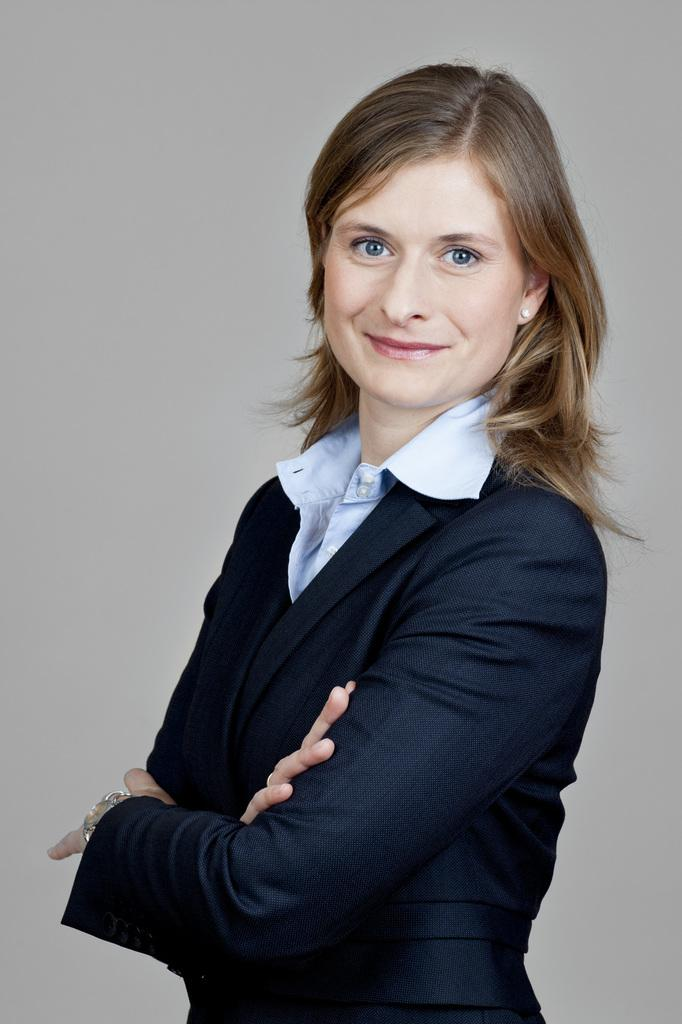Who is present in the image? There is a woman in the image. What expression does the woman have? The woman is smiling. What type of alarm is the woman holding in the image? There is no alarm present in the image; the woman is simply smiling. 